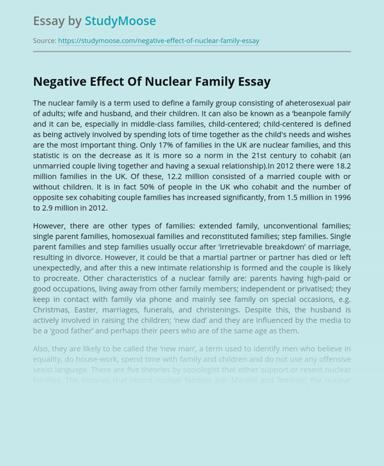What is the main topic discussed in the essay mentioned in the image?
 The main topic discussed in the essay is the negative effects of nuclear family and the various types of family structures. In the essay, what is the change that people have observed in family structures in the 21st century? In the 21st century, there is a decrease in the number of nuclear families, and it is more common for people to cohabit as an unmarried couple. The essay also mentions the increase in the number of opposite-sex cohabiting couple families. 